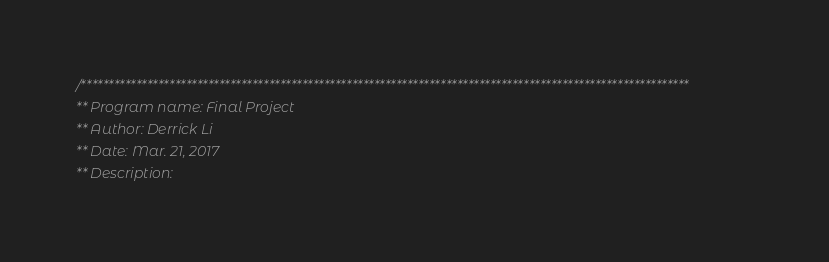Convert code to text. <code><loc_0><loc_0><loc_500><loc_500><_C++_>/**************************************************************************************************************
** Program name: Final Project
** Author: Derrick Li
** Date: Mar. 21, 2017
** Description:</code> 